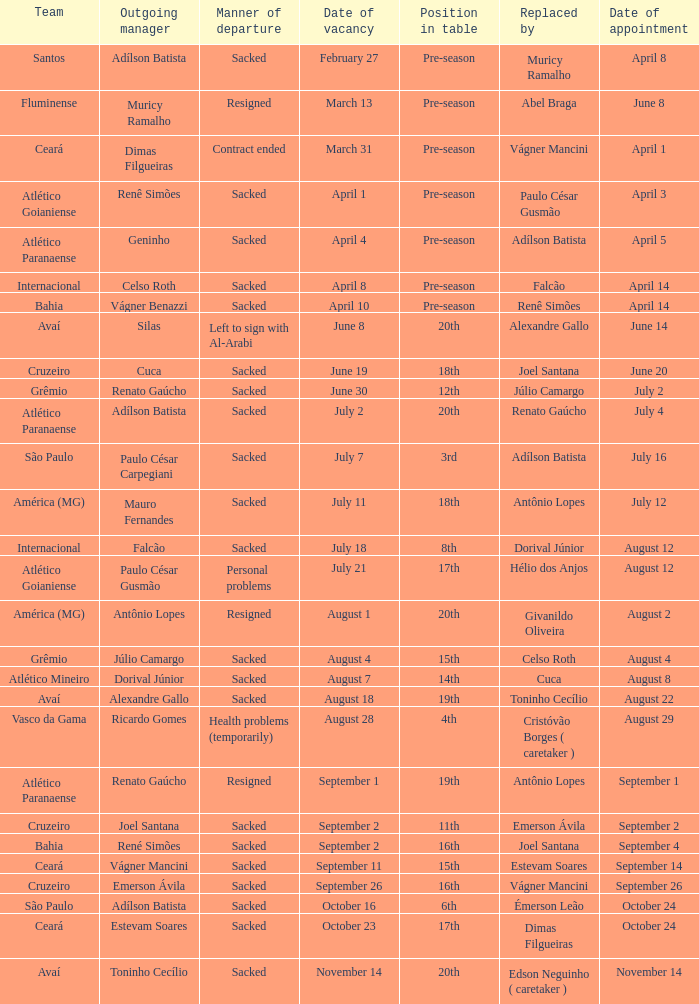For what cause did geninho step down from the managerial position? Sacked. 